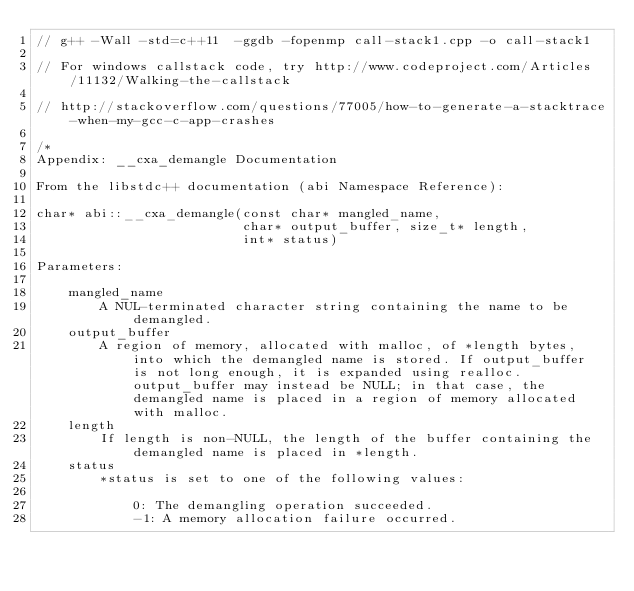<code> <loc_0><loc_0><loc_500><loc_500><_C++_>// g++ -Wall -std=c++11  -ggdb -fopenmp call-stack1.cpp -o call-stack1

// For windows callstack code, try http://www.codeproject.com/Articles/11132/Walking-the-callstack

// http://stackoverflow.com/questions/77005/how-to-generate-a-stacktrace-when-my-gcc-c-app-crashes

/*
Appendix: __cxa_demangle Documentation

From the libstdc++ documentation (abi Namespace Reference):

char* abi::__cxa_demangle(const char* mangled_name,
                          char* output_buffer, size_t* length,
                          int* status)

Parameters:

    mangled_name
        A NUL-terminated character string containing the name to be demangled.
    output_buffer
        A region of memory, allocated with malloc, of *length bytes, into which the demangled name is stored. If output_buffer is not long enough, it is expanded using realloc. output_buffer may instead be NULL; in that case, the demangled name is placed in a region of memory allocated with malloc.
    length
        If length is non-NULL, the length of the buffer containing the demangled name is placed in *length.
    status
        *status is set to one of the following values:

            0: The demangling operation succeeded.
            -1: A memory allocation failure occurred.</code> 